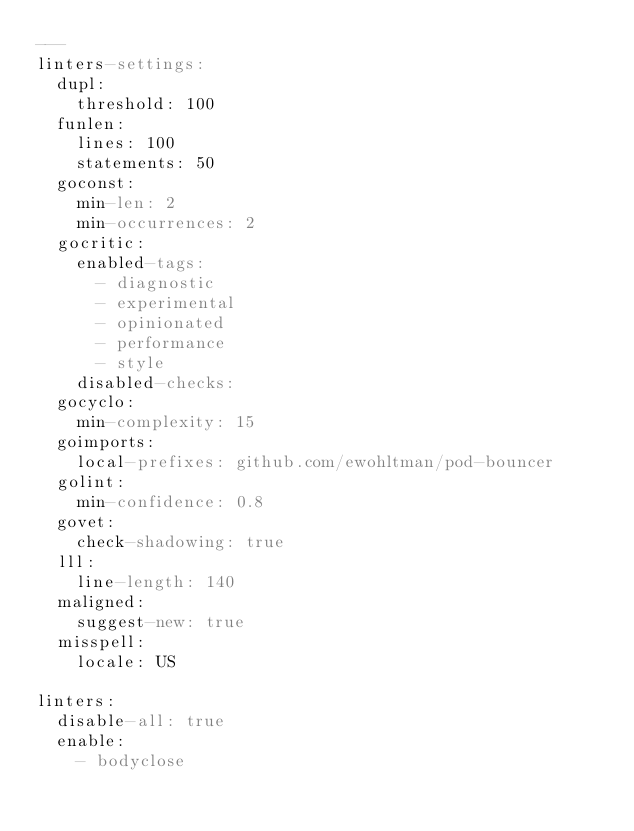<code> <loc_0><loc_0><loc_500><loc_500><_YAML_>---
linters-settings:
  dupl:
    threshold: 100
  funlen:
    lines: 100
    statements: 50
  goconst:
    min-len: 2
    min-occurrences: 2
  gocritic:
    enabled-tags:
      - diagnostic
      - experimental
      - opinionated
      - performance
      - style
    disabled-checks:
  gocyclo:
    min-complexity: 15
  goimports:
    local-prefixes: github.com/ewohltman/pod-bouncer
  golint:
    min-confidence: 0.8
  govet:
    check-shadowing: true
  lll:
    line-length: 140
  maligned:
    suggest-new: true
  misspell:
    locale: US

linters:
  disable-all: true
  enable:
    - bodyclose</code> 